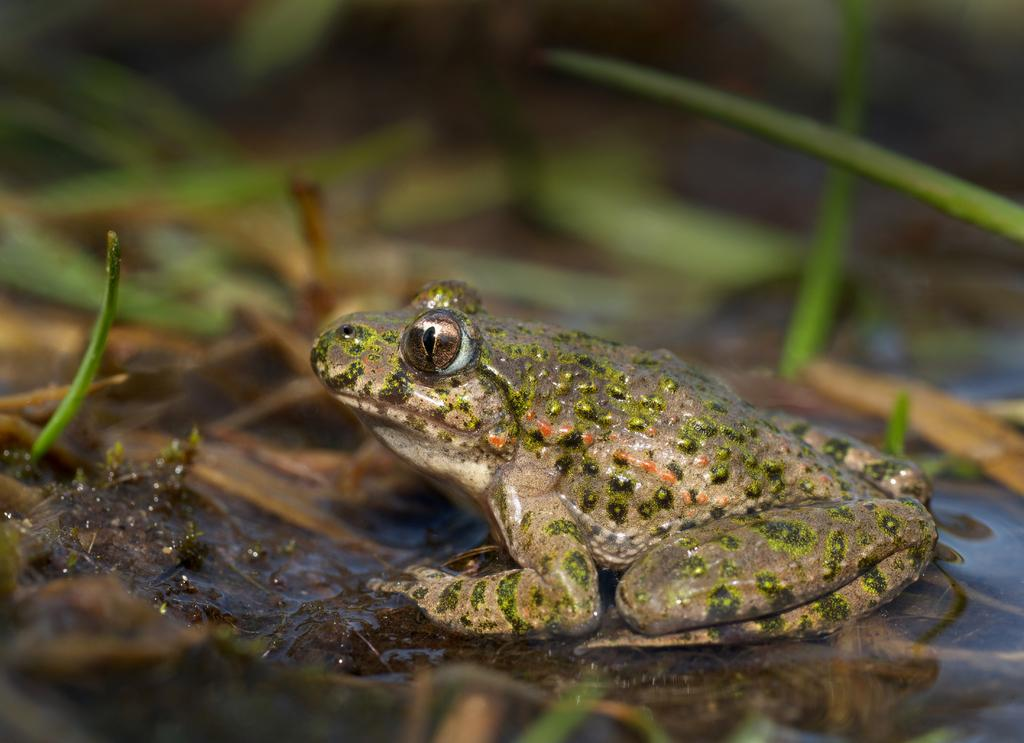What animal is the main subject of the picture? There is a frog in the picture. What is the frog doing in the picture? The frog is sitting on an object. What is the environment like around the frog? There is water around the frog. What type of lizards can be seen attacking the frog in the image? There are no lizards present in the image, and the frog is not being attacked. What is the frog using to carry water in the image? There is no bucket or any other container visible in the image, and the frog is not carrying water. 